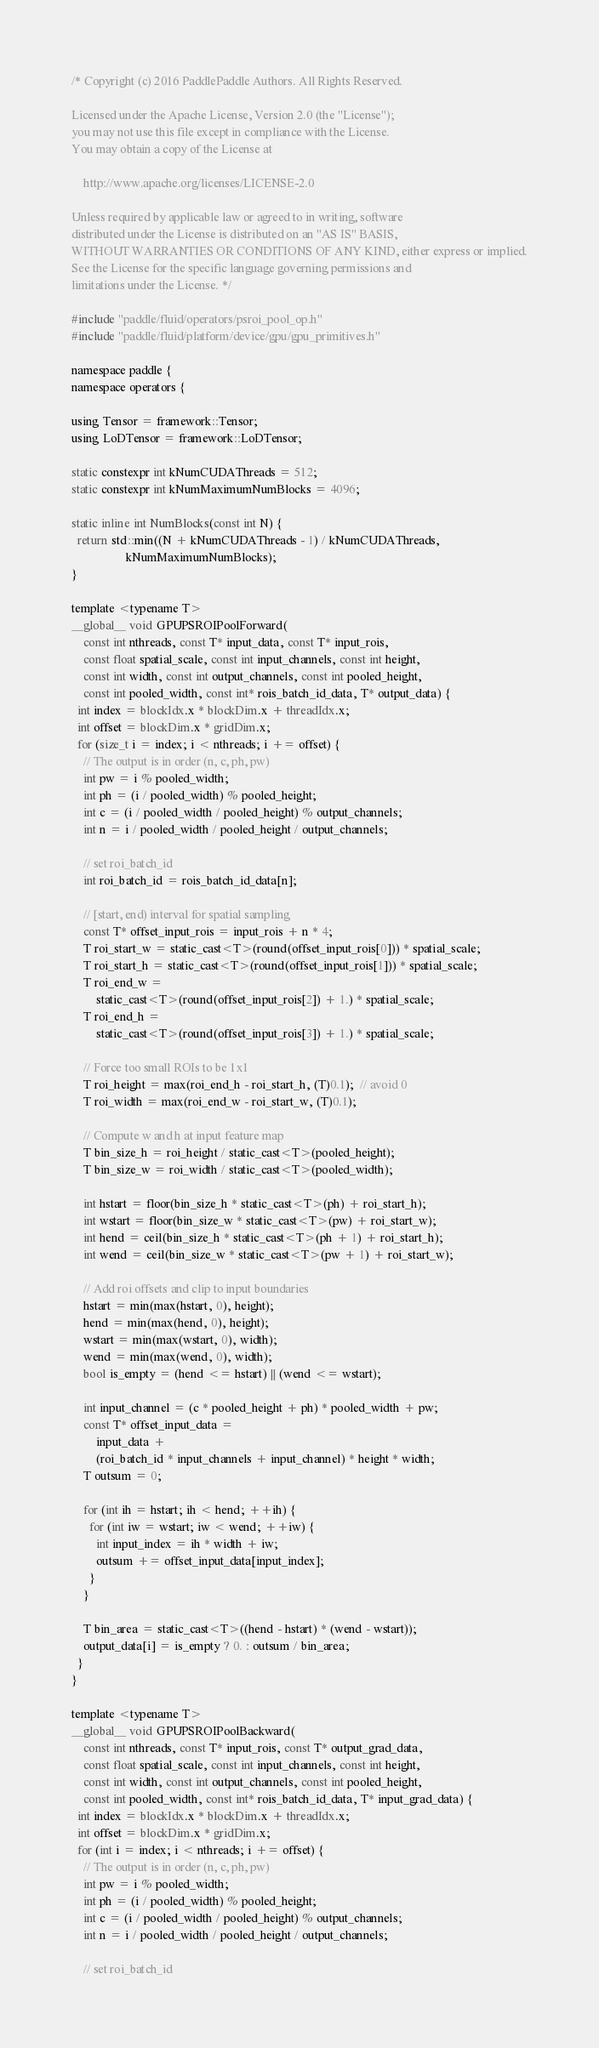Convert code to text. <code><loc_0><loc_0><loc_500><loc_500><_Cuda_>/* Copyright (c) 2016 PaddlePaddle Authors. All Rights Reserved.

Licensed under the Apache License, Version 2.0 (the "License");
you may not use this file except in compliance with the License.
You may obtain a copy of the License at

    http://www.apache.org/licenses/LICENSE-2.0

Unless required by applicable law or agreed to in writing, software
distributed under the License is distributed on an "AS IS" BASIS,
WITHOUT WARRANTIES OR CONDITIONS OF ANY KIND, either express or implied.
See the License for the specific language governing permissions and
limitations under the License. */

#include "paddle/fluid/operators/psroi_pool_op.h"
#include "paddle/fluid/platform/device/gpu/gpu_primitives.h"

namespace paddle {
namespace operators {

using Tensor = framework::Tensor;
using LoDTensor = framework::LoDTensor;

static constexpr int kNumCUDAThreads = 512;
static constexpr int kNumMaximumNumBlocks = 4096;

static inline int NumBlocks(const int N) {
  return std::min((N + kNumCUDAThreads - 1) / kNumCUDAThreads,
                  kNumMaximumNumBlocks);
}

template <typename T>
__global__ void GPUPSROIPoolForward(
    const int nthreads, const T* input_data, const T* input_rois,
    const float spatial_scale, const int input_channels, const int height,
    const int width, const int output_channels, const int pooled_height,
    const int pooled_width, const int* rois_batch_id_data, T* output_data) {
  int index = blockIdx.x * blockDim.x + threadIdx.x;
  int offset = blockDim.x * gridDim.x;
  for (size_t i = index; i < nthreads; i += offset) {
    // The output is in order (n, c, ph, pw)
    int pw = i % pooled_width;
    int ph = (i / pooled_width) % pooled_height;
    int c = (i / pooled_width / pooled_height) % output_channels;
    int n = i / pooled_width / pooled_height / output_channels;

    // set roi_batch_id
    int roi_batch_id = rois_batch_id_data[n];

    // [start, end) interval for spatial sampling
    const T* offset_input_rois = input_rois + n * 4;
    T roi_start_w = static_cast<T>(round(offset_input_rois[0])) * spatial_scale;
    T roi_start_h = static_cast<T>(round(offset_input_rois[1])) * spatial_scale;
    T roi_end_w =
        static_cast<T>(round(offset_input_rois[2]) + 1.) * spatial_scale;
    T roi_end_h =
        static_cast<T>(round(offset_input_rois[3]) + 1.) * spatial_scale;

    // Force too small ROIs to be 1x1
    T roi_height = max(roi_end_h - roi_start_h, (T)0.1);  // avoid 0
    T roi_width = max(roi_end_w - roi_start_w, (T)0.1);

    // Compute w and h at input feature map
    T bin_size_h = roi_height / static_cast<T>(pooled_height);
    T bin_size_w = roi_width / static_cast<T>(pooled_width);

    int hstart = floor(bin_size_h * static_cast<T>(ph) + roi_start_h);
    int wstart = floor(bin_size_w * static_cast<T>(pw) + roi_start_w);
    int hend = ceil(bin_size_h * static_cast<T>(ph + 1) + roi_start_h);
    int wend = ceil(bin_size_w * static_cast<T>(pw + 1) + roi_start_w);

    // Add roi offsets and clip to input boundaries
    hstart = min(max(hstart, 0), height);
    hend = min(max(hend, 0), height);
    wstart = min(max(wstart, 0), width);
    wend = min(max(wend, 0), width);
    bool is_empty = (hend <= hstart) || (wend <= wstart);

    int input_channel = (c * pooled_height + ph) * pooled_width + pw;
    const T* offset_input_data =
        input_data +
        (roi_batch_id * input_channels + input_channel) * height * width;
    T outsum = 0;

    for (int ih = hstart; ih < hend; ++ih) {
      for (int iw = wstart; iw < wend; ++iw) {
        int input_index = ih * width + iw;
        outsum += offset_input_data[input_index];
      }
    }

    T bin_area = static_cast<T>((hend - hstart) * (wend - wstart));
    output_data[i] = is_empty ? 0. : outsum / bin_area;
  }
}

template <typename T>
__global__ void GPUPSROIPoolBackward(
    const int nthreads, const T* input_rois, const T* output_grad_data,
    const float spatial_scale, const int input_channels, const int height,
    const int width, const int output_channels, const int pooled_height,
    const int pooled_width, const int* rois_batch_id_data, T* input_grad_data) {
  int index = blockIdx.x * blockDim.x + threadIdx.x;
  int offset = blockDim.x * gridDim.x;
  for (int i = index; i < nthreads; i += offset) {
    // The output is in order (n, c, ph, pw)
    int pw = i % pooled_width;
    int ph = (i / pooled_width) % pooled_height;
    int c = (i / pooled_width / pooled_height) % output_channels;
    int n = i / pooled_width / pooled_height / output_channels;

    // set roi_batch_id</code> 